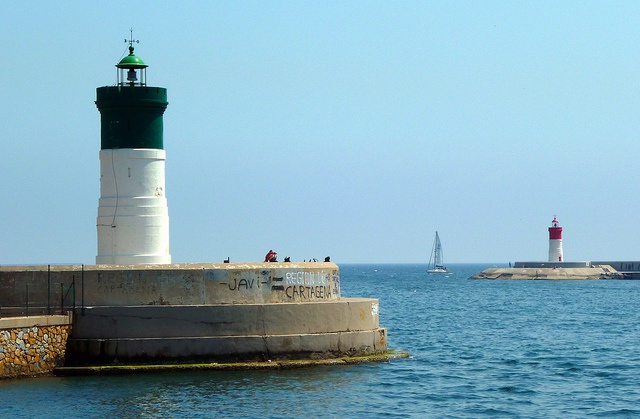Describe the objects in this image and their specific colors. I can see boat in lightblue and gray tones, people in lightblue, maroon, black, gray, and brown tones, and people in lightblue, black, gray, and purple tones in this image. 